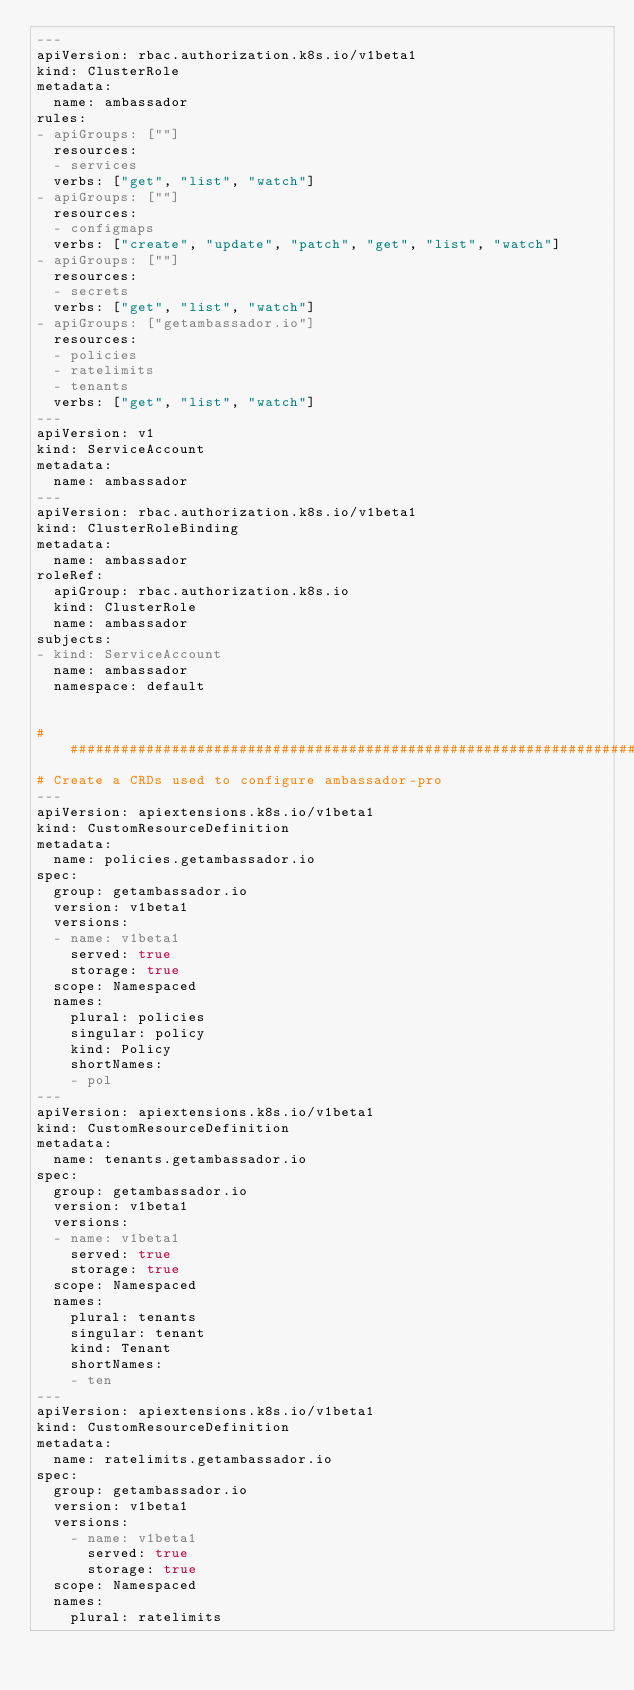<code> <loc_0><loc_0><loc_500><loc_500><_YAML_>---
apiVersion: rbac.authorization.k8s.io/v1beta1
kind: ClusterRole
metadata:
  name: ambassador
rules:
- apiGroups: [""]
  resources:
  - services
  verbs: ["get", "list", "watch"]
- apiGroups: [""]
  resources:
  - configmaps
  verbs: ["create", "update", "patch", "get", "list", "watch"]
- apiGroups: [""]
  resources:
  - secrets
  verbs: ["get", "list", "watch"]
- apiGroups: ["getambassador.io"]
  resources:
  - policies
  - ratelimits
  - tenants
  verbs: ["get", "list", "watch"]
---
apiVersion: v1
kind: ServiceAccount
metadata:
  name: ambassador
---
apiVersion: rbac.authorization.k8s.io/v1beta1
kind: ClusterRoleBinding
metadata:
  name: ambassador
roleRef:
  apiGroup: rbac.authorization.k8s.io
  kind: ClusterRole
  name: ambassador
subjects:
- kind: ServiceAccount
  name: ambassador
  namespace: default


######################################################################
# Create a CRDs used to configure ambassador-pro
---
apiVersion: apiextensions.k8s.io/v1beta1
kind: CustomResourceDefinition
metadata:
  name: policies.getambassador.io
spec:
  group: getambassador.io
  version: v1beta1
  versions:
  - name: v1beta1
    served: true
    storage: true
  scope: Namespaced
  names:
    plural: policies
    singular: policy
    kind: Policy
    shortNames:
    - pol
---
apiVersion: apiextensions.k8s.io/v1beta1
kind: CustomResourceDefinition
metadata:
  name: tenants.getambassador.io
spec:
  group: getambassador.io
  version: v1beta1
  versions:
  - name: v1beta1
    served: true
    storage: true
  scope: Namespaced
  names:
    plural: tenants
    singular: tenant
    kind: Tenant
    shortNames:
    - ten
---
apiVersion: apiextensions.k8s.io/v1beta1
kind: CustomResourceDefinition
metadata:
  name: ratelimits.getambassador.io
spec:
  group: getambassador.io
  version: v1beta1
  versions:
    - name: v1beta1
      served: true
      storage: true
  scope: Namespaced
  names:
    plural: ratelimits</code> 